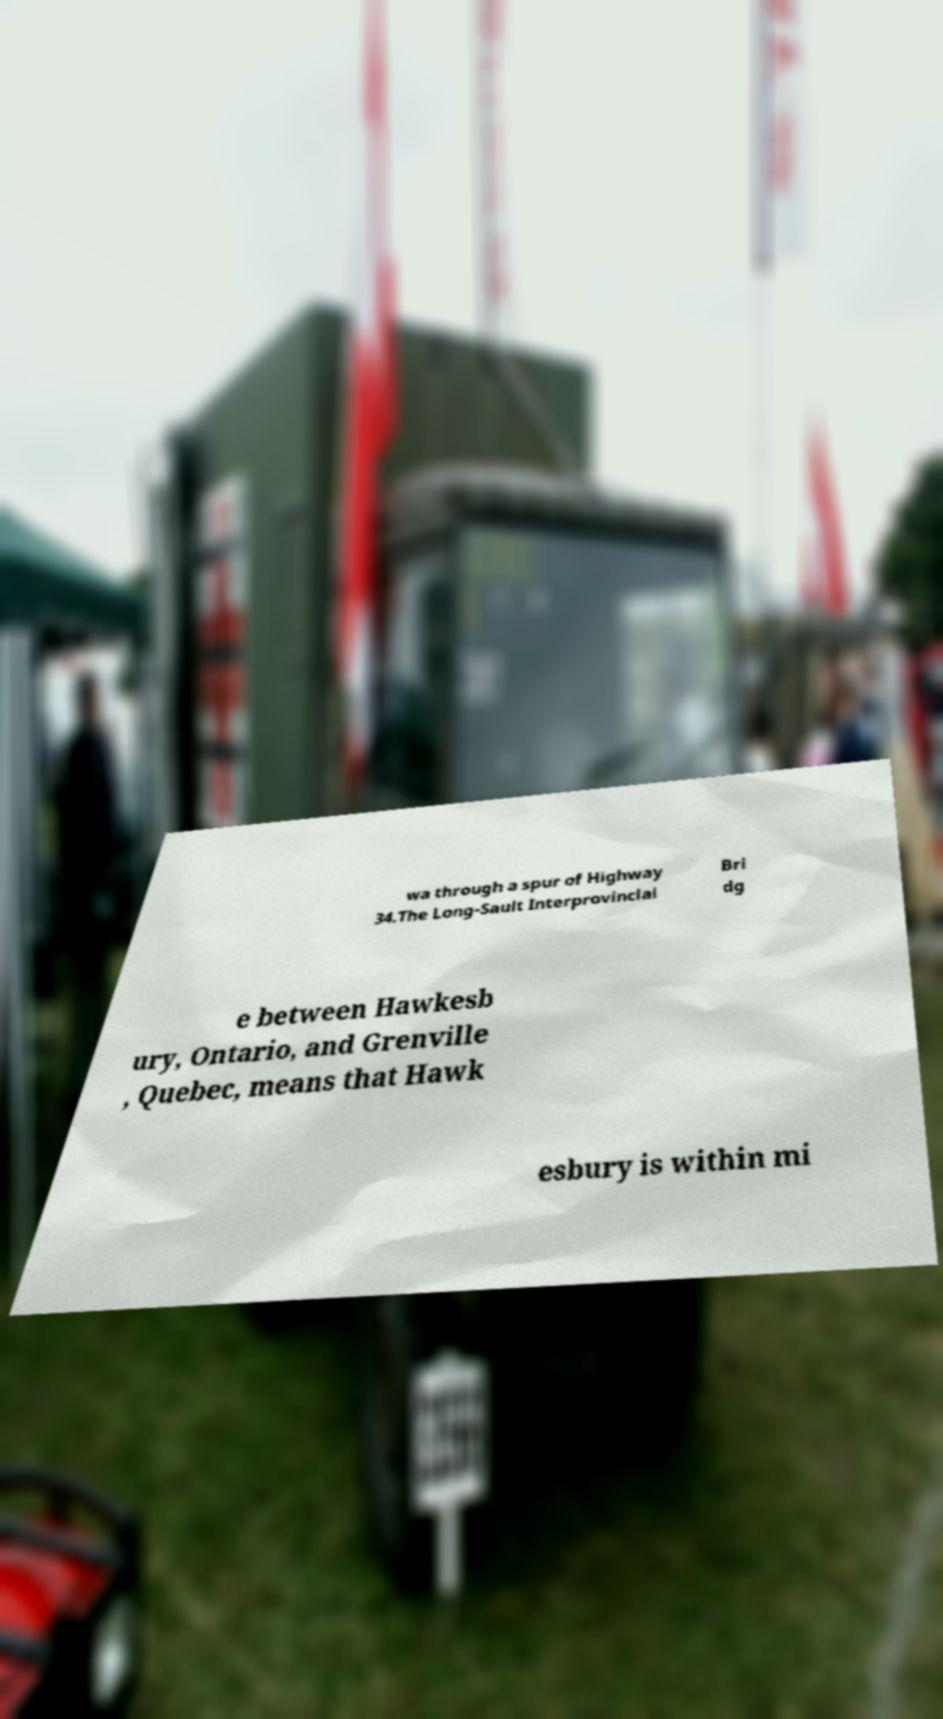Can you accurately transcribe the text from the provided image for me? wa through a spur of Highway 34.The Long-Sault Interprovincial Bri dg e between Hawkesb ury, Ontario, and Grenville , Quebec, means that Hawk esbury is within mi 